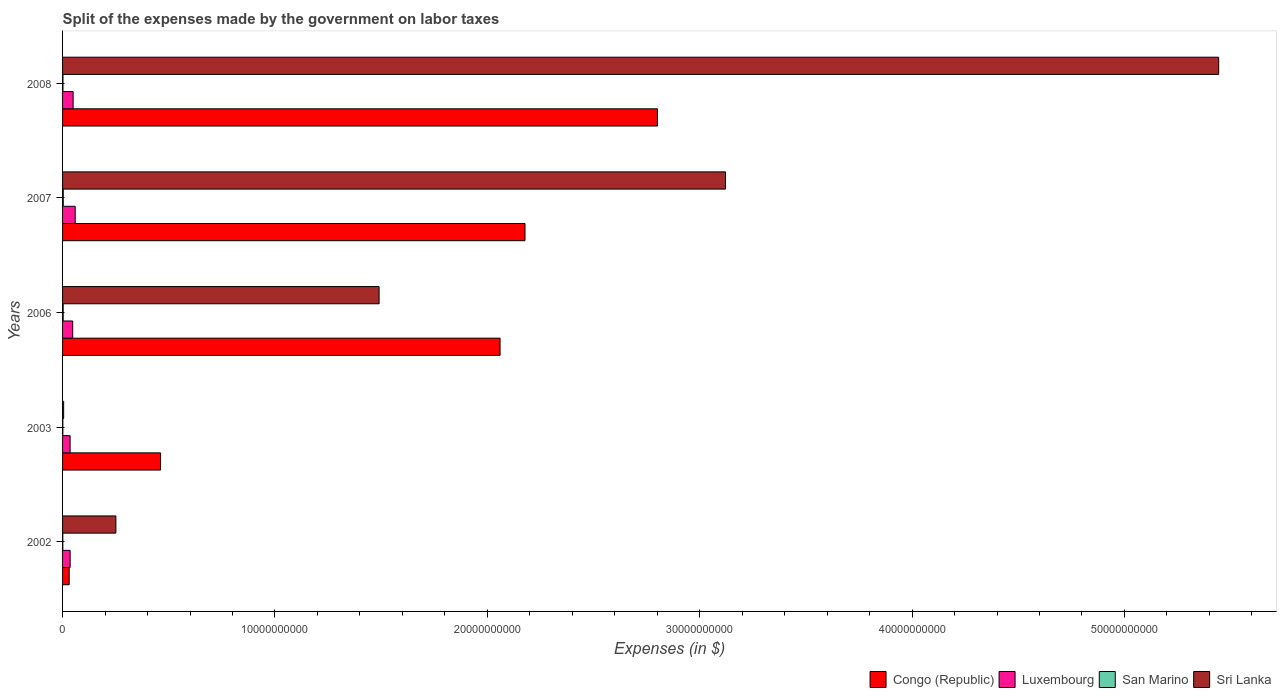Are the number of bars on each tick of the Y-axis equal?
Your answer should be compact. Yes. What is the label of the 5th group of bars from the top?
Provide a succinct answer. 2002. In how many cases, is the number of bars for a given year not equal to the number of legend labels?
Make the answer very short. 0. What is the expenses made by the government on labor taxes in San Marino in 2003?
Provide a succinct answer. 1.21e+07. Across all years, what is the maximum expenses made by the government on labor taxes in Congo (Republic)?
Make the answer very short. 2.80e+1. Across all years, what is the minimum expenses made by the government on labor taxes in San Marino?
Your answer should be compact. 1.16e+07. What is the total expenses made by the government on labor taxes in Congo (Republic) in the graph?
Provide a succinct answer. 7.53e+1. What is the difference between the expenses made by the government on labor taxes in Sri Lanka in 2006 and that in 2007?
Your answer should be very brief. -1.63e+1. What is the difference between the expenses made by the government on labor taxes in Congo (Republic) in 2006 and the expenses made by the government on labor taxes in San Marino in 2008?
Ensure brevity in your answer.  2.06e+1. What is the average expenses made by the government on labor taxes in San Marino per year?
Offer a very short reply. 2.05e+07. In the year 2008, what is the difference between the expenses made by the government on labor taxes in Luxembourg and expenses made by the government on labor taxes in Sri Lanka?
Offer a very short reply. -5.39e+1. In how many years, is the expenses made by the government on labor taxes in Congo (Republic) greater than 26000000000 $?
Ensure brevity in your answer.  1. What is the ratio of the expenses made by the government on labor taxes in San Marino in 2003 to that in 2008?
Your response must be concise. 0.65. Is the expenses made by the government on labor taxes in San Marino in 2002 less than that in 2008?
Your answer should be compact. Yes. What is the difference between the highest and the second highest expenses made by the government on labor taxes in Sri Lanka?
Provide a succinct answer. 2.32e+1. What is the difference between the highest and the lowest expenses made by the government on labor taxes in Luxembourg?
Make the answer very short. 2.40e+08. What does the 1st bar from the top in 2006 represents?
Provide a succinct answer. Sri Lanka. What does the 2nd bar from the bottom in 2006 represents?
Give a very brief answer. Luxembourg. Is it the case that in every year, the sum of the expenses made by the government on labor taxes in San Marino and expenses made by the government on labor taxes in Sri Lanka is greater than the expenses made by the government on labor taxes in Congo (Republic)?
Offer a terse response. No. How many years are there in the graph?
Your answer should be very brief. 5. Where does the legend appear in the graph?
Keep it short and to the point. Bottom right. How many legend labels are there?
Provide a succinct answer. 4. How are the legend labels stacked?
Ensure brevity in your answer.  Horizontal. What is the title of the graph?
Ensure brevity in your answer.  Split of the expenses made by the government on labor taxes. What is the label or title of the X-axis?
Make the answer very short. Expenses (in $). What is the label or title of the Y-axis?
Provide a short and direct response. Years. What is the Expenses (in $) in Congo (Republic) in 2002?
Your answer should be very brief. 3.12e+08. What is the Expenses (in $) of Luxembourg in 2002?
Offer a terse response. 3.56e+08. What is the Expenses (in $) in San Marino in 2002?
Offer a very short reply. 1.16e+07. What is the Expenses (in $) in Sri Lanka in 2002?
Your answer should be compact. 2.51e+09. What is the Expenses (in $) in Congo (Republic) in 2003?
Your answer should be very brief. 4.61e+09. What is the Expenses (in $) in Luxembourg in 2003?
Give a very brief answer. 3.54e+08. What is the Expenses (in $) of San Marino in 2003?
Offer a very short reply. 1.21e+07. What is the Expenses (in $) of Sri Lanka in 2003?
Offer a very short reply. 5.10e+07. What is the Expenses (in $) of Congo (Republic) in 2006?
Your answer should be compact. 2.06e+1. What is the Expenses (in $) of Luxembourg in 2006?
Offer a terse response. 4.78e+08. What is the Expenses (in $) in San Marino in 2006?
Your answer should be compact. 2.84e+07. What is the Expenses (in $) of Sri Lanka in 2006?
Ensure brevity in your answer.  1.49e+1. What is the Expenses (in $) in Congo (Republic) in 2007?
Offer a very short reply. 2.18e+1. What is the Expenses (in $) in Luxembourg in 2007?
Give a very brief answer. 5.95e+08. What is the Expenses (in $) of San Marino in 2007?
Offer a terse response. 3.20e+07. What is the Expenses (in $) in Sri Lanka in 2007?
Provide a succinct answer. 3.12e+1. What is the Expenses (in $) in Congo (Republic) in 2008?
Your response must be concise. 2.80e+1. What is the Expenses (in $) of Luxembourg in 2008?
Your response must be concise. 4.97e+08. What is the Expenses (in $) in San Marino in 2008?
Your response must be concise. 1.87e+07. What is the Expenses (in $) of Sri Lanka in 2008?
Your answer should be compact. 5.44e+1. Across all years, what is the maximum Expenses (in $) in Congo (Republic)?
Provide a short and direct response. 2.80e+1. Across all years, what is the maximum Expenses (in $) of Luxembourg?
Make the answer very short. 5.95e+08. Across all years, what is the maximum Expenses (in $) of San Marino?
Offer a terse response. 3.20e+07. Across all years, what is the maximum Expenses (in $) in Sri Lanka?
Your answer should be compact. 5.44e+1. Across all years, what is the minimum Expenses (in $) of Congo (Republic)?
Your answer should be compact. 3.12e+08. Across all years, what is the minimum Expenses (in $) of Luxembourg?
Your response must be concise. 3.54e+08. Across all years, what is the minimum Expenses (in $) in San Marino?
Offer a very short reply. 1.16e+07. Across all years, what is the minimum Expenses (in $) of Sri Lanka?
Your answer should be compact. 5.10e+07. What is the total Expenses (in $) of Congo (Republic) in the graph?
Your answer should be very brief. 7.53e+1. What is the total Expenses (in $) of Luxembourg in the graph?
Give a very brief answer. 2.28e+09. What is the total Expenses (in $) in San Marino in the graph?
Give a very brief answer. 1.03e+08. What is the total Expenses (in $) of Sri Lanka in the graph?
Make the answer very short. 1.03e+11. What is the difference between the Expenses (in $) in Congo (Republic) in 2002 and that in 2003?
Your answer should be very brief. -4.30e+09. What is the difference between the Expenses (in $) in Luxembourg in 2002 and that in 2003?
Ensure brevity in your answer.  2.10e+06. What is the difference between the Expenses (in $) of San Marino in 2002 and that in 2003?
Offer a terse response. -5.42e+05. What is the difference between the Expenses (in $) in Sri Lanka in 2002 and that in 2003?
Offer a terse response. 2.46e+09. What is the difference between the Expenses (in $) of Congo (Republic) in 2002 and that in 2006?
Keep it short and to the point. -2.03e+1. What is the difference between the Expenses (in $) in Luxembourg in 2002 and that in 2006?
Offer a terse response. -1.22e+08. What is the difference between the Expenses (in $) of San Marino in 2002 and that in 2006?
Your answer should be very brief. -1.69e+07. What is the difference between the Expenses (in $) in Sri Lanka in 2002 and that in 2006?
Provide a short and direct response. -1.24e+1. What is the difference between the Expenses (in $) in Congo (Republic) in 2002 and that in 2007?
Provide a succinct answer. -2.15e+1. What is the difference between the Expenses (in $) of Luxembourg in 2002 and that in 2007?
Your answer should be very brief. -2.38e+08. What is the difference between the Expenses (in $) in San Marino in 2002 and that in 2007?
Provide a short and direct response. -2.04e+07. What is the difference between the Expenses (in $) in Sri Lanka in 2002 and that in 2007?
Your answer should be compact. -2.87e+1. What is the difference between the Expenses (in $) of Congo (Republic) in 2002 and that in 2008?
Offer a terse response. -2.77e+1. What is the difference between the Expenses (in $) of Luxembourg in 2002 and that in 2008?
Make the answer very short. -1.41e+08. What is the difference between the Expenses (in $) in San Marino in 2002 and that in 2008?
Your answer should be very brief. -7.12e+06. What is the difference between the Expenses (in $) in Sri Lanka in 2002 and that in 2008?
Give a very brief answer. -5.19e+1. What is the difference between the Expenses (in $) in Congo (Republic) in 2003 and that in 2006?
Offer a terse response. -1.60e+1. What is the difference between the Expenses (in $) in Luxembourg in 2003 and that in 2006?
Keep it short and to the point. -1.24e+08. What is the difference between the Expenses (in $) of San Marino in 2003 and that in 2006?
Your response must be concise. -1.63e+07. What is the difference between the Expenses (in $) of Sri Lanka in 2003 and that in 2006?
Your response must be concise. -1.49e+1. What is the difference between the Expenses (in $) in Congo (Republic) in 2003 and that in 2007?
Provide a short and direct response. -1.72e+1. What is the difference between the Expenses (in $) in Luxembourg in 2003 and that in 2007?
Provide a succinct answer. -2.40e+08. What is the difference between the Expenses (in $) in San Marino in 2003 and that in 2007?
Your answer should be very brief. -1.99e+07. What is the difference between the Expenses (in $) in Sri Lanka in 2003 and that in 2007?
Provide a short and direct response. -3.12e+1. What is the difference between the Expenses (in $) in Congo (Republic) in 2003 and that in 2008?
Ensure brevity in your answer.  -2.34e+1. What is the difference between the Expenses (in $) in Luxembourg in 2003 and that in 2008?
Provide a short and direct response. -1.43e+08. What is the difference between the Expenses (in $) in San Marino in 2003 and that in 2008?
Give a very brief answer. -6.58e+06. What is the difference between the Expenses (in $) in Sri Lanka in 2003 and that in 2008?
Make the answer very short. -5.44e+1. What is the difference between the Expenses (in $) of Congo (Republic) in 2006 and that in 2007?
Provide a short and direct response. -1.17e+09. What is the difference between the Expenses (in $) of Luxembourg in 2006 and that in 2007?
Provide a short and direct response. -1.17e+08. What is the difference between the Expenses (in $) of San Marino in 2006 and that in 2007?
Offer a very short reply. -3.56e+06. What is the difference between the Expenses (in $) of Sri Lanka in 2006 and that in 2007?
Your response must be concise. -1.63e+1. What is the difference between the Expenses (in $) in Congo (Republic) in 2006 and that in 2008?
Give a very brief answer. -7.41e+09. What is the difference between the Expenses (in $) of Luxembourg in 2006 and that in 2008?
Your response must be concise. -1.92e+07. What is the difference between the Expenses (in $) in San Marino in 2006 and that in 2008?
Keep it short and to the point. 9.73e+06. What is the difference between the Expenses (in $) in Sri Lanka in 2006 and that in 2008?
Offer a very short reply. -3.95e+1. What is the difference between the Expenses (in $) of Congo (Republic) in 2007 and that in 2008?
Make the answer very short. -6.24e+09. What is the difference between the Expenses (in $) in Luxembourg in 2007 and that in 2008?
Give a very brief answer. 9.75e+07. What is the difference between the Expenses (in $) of San Marino in 2007 and that in 2008?
Offer a terse response. 1.33e+07. What is the difference between the Expenses (in $) of Sri Lanka in 2007 and that in 2008?
Keep it short and to the point. -2.32e+1. What is the difference between the Expenses (in $) in Congo (Republic) in 2002 and the Expenses (in $) in Luxembourg in 2003?
Give a very brief answer. -4.24e+07. What is the difference between the Expenses (in $) of Congo (Republic) in 2002 and the Expenses (in $) of San Marino in 2003?
Make the answer very short. 3.00e+08. What is the difference between the Expenses (in $) of Congo (Republic) in 2002 and the Expenses (in $) of Sri Lanka in 2003?
Keep it short and to the point. 2.61e+08. What is the difference between the Expenses (in $) in Luxembourg in 2002 and the Expenses (in $) in San Marino in 2003?
Offer a very short reply. 3.44e+08. What is the difference between the Expenses (in $) of Luxembourg in 2002 and the Expenses (in $) of Sri Lanka in 2003?
Ensure brevity in your answer.  3.05e+08. What is the difference between the Expenses (in $) in San Marino in 2002 and the Expenses (in $) in Sri Lanka in 2003?
Offer a very short reply. -3.94e+07. What is the difference between the Expenses (in $) in Congo (Republic) in 2002 and the Expenses (in $) in Luxembourg in 2006?
Ensure brevity in your answer.  -1.66e+08. What is the difference between the Expenses (in $) of Congo (Republic) in 2002 and the Expenses (in $) of San Marino in 2006?
Make the answer very short. 2.83e+08. What is the difference between the Expenses (in $) of Congo (Republic) in 2002 and the Expenses (in $) of Sri Lanka in 2006?
Make the answer very short. -1.46e+1. What is the difference between the Expenses (in $) of Luxembourg in 2002 and the Expenses (in $) of San Marino in 2006?
Your answer should be very brief. 3.28e+08. What is the difference between the Expenses (in $) of Luxembourg in 2002 and the Expenses (in $) of Sri Lanka in 2006?
Your response must be concise. -1.45e+1. What is the difference between the Expenses (in $) in San Marino in 2002 and the Expenses (in $) in Sri Lanka in 2006?
Give a very brief answer. -1.49e+1. What is the difference between the Expenses (in $) of Congo (Republic) in 2002 and the Expenses (in $) of Luxembourg in 2007?
Provide a short and direct response. -2.83e+08. What is the difference between the Expenses (in $) in Congo (Republic) in 2002 and the Expenses (in $) in San Marino in 2007?
Make the answer very short. 2.80e+08. What is the difference between the Expenses (in $) of Congo (Republic) in 2002 and the Expenses (in $) of Sri Lanka in 2007?
Your answer should be very brief. -3.09e+1. What is the difference between the Expenses (in $) in Luxembourg in 2002 and the Expenses (in $) in San Marino in 2007?
Make the answer very short. 3.24e+08. What is the difference between the Expenses (in $) in Luxembourg in 2002 and the Expenses (in $) in Sri Lanka in 2007?
Make the answer very short. -3.09e+1. What is the difference between the Expenses (in $) of San Marino in 2002 and the Expenses (in $) of Sri Lanka in 2007?
Keep it short and to the point. -3.12e+1. What is the difference between the Expenses (in $) in Congo (Republic) in 2002 and the Expenses (in $) in Luxembourg in 2008?
Provide a short and direct response. -1.85e+08. What is the difference between the Expenses (in $) of Congo (Republic) in 2002 and the Expenses (in $) of San Marino in 2008?
Give a very brief answer. 2.93e+08. What is the difference between the Expenses (in $) of Congo (Republic) in 2002 and the Expenses (in $) of Sri Lanka in 2008?
Your answer should be compact. -5.41e+1. What is the difference between the Expenses (in $) of Luxembourg in 2002 and the Expenses (in $) of San Marino in 2008?
Give a very brief answer. 3.38e+08. What is the difference between the Expenses (in $) of Luxembourg in 2002 and the Expenses (in $) of Sri Lanka in 2008?
Offer a very short reply. -5.41e+1. What is the difference between the Expenses (in $) of San Marino in 2002 and the Expenses (in $) of Sri Lanka in 2008?
Offer a terse response. -5.44e+1. What is the difference between the Expenses (in $) of Congo (Republic) in 2003 and the Expenses (in $) of Luxembourg in 2006?
Your answer should be compact. 4.14e+09. What is the difference between the Expenses (in $) of Congo (Republic) in 2003 and the Expenses (in $) of San Marino in 2006?
Provide a succinct answer. 4.59e+09. What is the difference between the Expenses (in $) of Congo (Republic) in 2003 and the Expenses (in $) of Sri Lanka in 2006?
Offer a terse response. -1.03e+1. What is the difference between the Expenses (in $) of Luxembourg in 2003 and the Expenses (in $) of San Marino in 2006?
Give a very brief answer. 3.26e+08. What is the difference between the Expenses (in $) of Luxembourg in 2003 and the Expenses (in $) of Sri Lanka in 2006?
Your answer should be very brief. -1.46e+1. What is the difference between the Expenses (in $) of San Marino in 2003 and the Expenses (in $) of Sri Lanka in 2006?
Give a very brief answer. -1.49e+1. What is the difference between the Expenses (in $) in Congo (Republic) in 2003 and the Expenses (in $) in Luxembourg in 2007?
Your response must be concise. 4.02e+09. What is the difference between the Expenses (in $) in Congo (Republic) in 2003 and the Expenses (in $) in San Marino in 2007?
Give a very brief answer. 4.58e+09. What is the difference between the Expenses (in $) in Congo (Republic) in 2003 and the Expenses (in $) in Sri Lanka in 2007?
Provide a succinct answer. -2.66e+1. What is the difference between the Expenses (in $) in Luxembourg in 2003 and the Expenses (in $) in San Marino in 2007?
Provide a succinct answer. 3.22e+08. What is the difference between the Expenses (in $) of Luxembourg in 2003 and the Expenses (in $) of Sri Lanka in 2007?
Make the answer very short. -3.09e+1. What is the difference between the Expenses (in $) of San Marino in 2003 and the Expenses (in $) of Sri Lanka in 2007?
Your answer should be compact. -3.12e+1. What is the difference between the Expenses (in $) in Congo (Republic) in 2003 and the Expenses (in $) in Luxembourg in 2008?
Keep it short and to the point. 4.12e+09. What is the difference between the Expenses (in $) in Congo (Republic) in 2003 and the Expenses (in $) in San Marino in 2008?
Offer a terse response. 4.60e+09. What is the difference between the Expenses (in $) of Congo (Republic) in 2003 and the Expenses (in $) of Sri Lanka in 2008?
Give a very brief answer. -4.98e+1. What is the difference between the Expenses (in $) in Luxembourg in 2003 and the Expenses (in $) in San Marino in 2008?
Provide a succinct answer. 3.36e+08. What is the difference between the Expenses (in $) of Luxembourg in 2003 and the Expenses (in $) of Sri Lanka in 2008?
Provide a short and direct response. -5.41e+1. What is the difference between the Expenses (in $) of San Marino in 2003 and the Expenses (in $) of Sri Lanka in 2008?
Provide a short and direct response. -5.44e+1. What is the difference between the Expenses (in $) in Congo (Republic) in 2006 and the Expenses (in $) in Luxembourg in 2007?
Offer a very short reply. 2.00e+1. What is the difference between the Expenses (in $) in Congo (Republic) in 2006 and the Expenses (in $) in San Marino in 2007?
Ensure brevity in your answer.  2.06e+1. What is the difference between the Expenses (in $) of Congo (Republic) in 2006 and the Expenses (in $) of Sri Lanka in 2007?
Offer a terse response. -1.06e+1. What is the difference between the Expenses (in $) of Luxembourg in 2006 and the Expenses (in $) of San Marino in 2007?
Keep it short and to the point. 4.46e+08. What is the difference between the Expenses (in $) of Luxembourg in 2006 and the Expenses (in $) of Sri Lanka in 2007?
Offer a terse response. -3.07e+1. What is the difference between the Expenses (in $) of San Marino in 2006 and the Expenses (in $) of Sri Lanka in 2007?
Ensure brevity in your answer.  -3.12e+1. What is the difference between the Expenses (in $) of Congo (Republic) in 2006 and the Expenses (in $) of Luxembourg in 2008?
Make the answer very short. 2.01e+1. What is the difference between the Expenses (in $) in Congo (Republic) in 2006 and the Expenses (in $) in San Marino in 2008?
Provide a succinct answer. 2.06e+1. What is the difference between the Expenses (in $) in Congo (Republic) in 2006 and the Expenses (in $) in Sri Lanka in 2008?
Offer a terse response. -3.38e+1. What is the difference between the Expenses (in $) of Luxembourg in 2006 and the Expenses (in $) of San Marino in 2008?
Offer a very short reply. 4.59e+08. What is the difference between the Expenses (in $) of Luxembourg in 2006 and the Expenses (in $) of Sri Lanka in 2008?
Ensure brevity in your answer.  -5.40e+1. What is the difference between the Expenses (in $) of San Marino in 2006 and the Expenses (in $) of Sri Lanka in 2008?
Give a very brief answer. -5.44e+1. What is the difference between the Expenses (in $) in Congo (Republic) in 2007 and the Expenses (in $) in Luxembourg in 2008?
Offer a very short reply. 2.13e+1. What is the difference between the Expenses (in $) in Congo (Republic) in 2007 and the Expenses (in $) in San Marino in 2008?
Make the answer very short. 2.18e+1. What is the difference between the Expenses (in $) in Congo (Republic) in 2007 and the Expenses (in $) in Sri Lanka in 2008?
Your answer should be very brief. -3.27e+1. What is the difference between the Expenses (in $) of Luxembourg in 2007 and the Expenses (in $) of San Marino in 2008?
Give a very brief answer. 5.76e+08. What is the difference between the Expenses (in $) of Luxembourg in 2007 and the Expenses (in $) of Sri Lanka in 2008?
Provide a short and direct response. -5.38e+1. What is the difference between the Expenses (in $) of San Marino in 2007 and the Expenses (in $) of Sri Lanka in 2008?
Ensure brevity in your answer.  -5.44e+1. What is the average Expenses (in $) in Congo (Republic) per year?
Provide a succinct answer. 1.51e+1. What is the average Expenses (in $) in Luxembourg per year?
Give a very brief answer. 4.56e+08. What is the average Expenses (in $) in San Marino per year?
Keep it short and to the point. 2.05e+07. What is the average Expenses (in $) of Sri Lanka per year?
Offer a terse response. 2.06e+1. In the year 2002, what is the difference between the Expenses (in $) in Congo (Republic) and Expenses (in $) in Luxembourg?
Provide a succinct answer. -4.45e+07. In the year 2002, what is the difference between the Expenses (in $) in Congo (Republic) and Expenses (in $) in San Marino?
Ensure brevity in your answer.  3.00e+08. In the year 2002, what is the difference between the Expenses (in $) in Congo (Republic) and Expenses (in $) in Sri Lanka?
Ensure brevity in your answer.  -2.20e+09. In the year 2002, what is the difference between the Expenses (in $) in Luxembourg and Expenses (in $) in San Marino?
Offer a terse response. 3.45e+08. In the year 2002, what is the difference between the Expenses (in $) in Luxembourg and Expenses (in $) in Sri Lanka?
Keep it short and to the point. -2.15e+09. In the year 2002, what is the difference between the Expenses (in $) in San Marino and Expenses (in $) in Sri Lanka?
Your answer should be compact. -2.50e+09. In the year 2003, what is the difference between the Expenses (in $) of Congo (Republic) and Expenses (in $) of Luxembourg?
Offer a terse response. 4.26e+09. In the year 2003, what is the difference between the Expenses (in $) of Congo (Republic) and Expenses (in $) of San Marino?
Offer a terse response. 4.60e+09. In the year 2003, what is the difference between the Expenses (in $) in Congo (Republic) and Expenses (in $) in Sri Lanka?
Your answer should be compact. 4.56e+09. In the year 2003, what is the difference between the Expenses (in $) in Luxembourg and Expenses (in $) in San Marino?
Provide a succinct answer. 3.42e+08. In the year 2003, what is the difference between the Expenses (in $) in Luxembourg and Expenses (in $) in Sri Lanka?
Make the answer very short. 3.03e+08. In the year 2003, what is the difference between the Expenses (in $) of San Marino and Expenses (in $) of Sri Lanka?
Make the answer very short. -3.89e+07. In the year 2006, what is the difference between the Expenses (in $) in Congo (Republic) and Expenses (in $) in Luxembourg?
Ensure brevity in your answer.  2.01e+1. In the year 2006, what is the difference between the Expenses (in $) of Congo (Republic) and Expenses (in $) of San Marino?
Your response must be concise. 2.06e+1. In the year 2006, what is the difference between the Expenses (in $) of Congo (Republic) and Expenses (in $) of Sri Lanka?
Provide a succinct answer. 5.70e+09. In the year 2006, what is the difference between the Expenses (in $) in Luxembourg and Expenses (in $) in San Marino?
Provide a succinct answer. 4.50e+08. In the year 2006, what is the difference between the Expenses (in $) in Luxembourg and Expenses (in $) in Sri Lanka?
Ensure brevity in your answer.  -1.44e+1. In the year 2006, what is the difference between the Expenses (in $) of San Marino and Expenses (in $) of Sri Lanka?
Keep it short and to the point. -1.49e+1. In the year 2007, what is the difference between the Expenses (in $) of Congo (Republic) and Expenses (in $) of Luxembourg?
Ensure brevity in your answer.  2.12e+1. In the year 2007, what is the difference between the Expenses (in $) in Congo (Republic) and Expenses (in $) in San Marino?
Your answer should be very brief. 2.17e+1. In the year 2007, what is the difference between the Expenses (in $) of Congo (Republic) and Expenses (in $) of Sri Lanka?
Your answer should be compact. -9.44e+09. In the year 2007, what is the difference between the Expenses (in $) in Luxembourg and Expenses (in $) in San Marino?
Your response must be concise. 5.63e+08. In the year 2007, what is the difference between the Expenses (in $) of Luxembourg and Expenses (in $) of Sri Lanka?
Ensure brevity in your answer.  -3.06e+1. In the year 2007, what is the difference between the Expenses (in $) of San Marino and Expenses (in $) of Sri Lanka?
Give a very brief answer. -3.12e+1. In the year 2008, what is the difference between the Expenses (in $) in Congo (Republic) and Expenses (in $) in Luxembourg?
Offer a very short reply. 2.75e+1. In the year 2008, what is the difference between the Expenses (in $) in Congo (Republic) and Expenses (in $) in San Marino?
Keep it short and to the point. 2.80e+1. In the year 2008, what is the difference between the Expenses (in $) of Congo (Republic) and Expenses (in $) of Sri Lanka?
Ensure brevity in your answer.  -2.64e+1. In the year 2008, what is the difference between the Expenses (in $) in Luxembourg and Expenses (in $) in San Marino?
Provide a succinct answer. 4.79e+08. In the year 2008, what is the difference between the Expenses (in $) of Luxembourg and Expenses (in $) of Sri Lanka?
Your response must be concise. -5.39e+1. In the year 2008, what is the difference between the Expenses (in $) in San Marino and Expenses (in $) in Sri Lanka?
Your response must be concise. -5.44e+1. What is the ratio of the Expenses (in $) in Congo (Republic) in 2002 to that in 2003?
Provide a short and direct response. 0.07. What is the ratio of the Expenses (in $) in Luxembourg in 2002 to that in 2003?
Give a very brief answer. 1.01. What is the ratio of the Expenses (in $) in San Marino in 2002 to that in 2003?
Your answer should be compact. 0.96. What is the ratio of the Expenses (in $) of Sri Lanka in 2002 to that in 2003?
Offer a terse response. 49.24. What is the ratio of the Expenses (in $) in Congo (Republic) in 2002 to that in 2006?
Ensure brevity in your answer.  0.02. What is the ratio of the Expenses (in $) in Luxembourg in 2002 to that in 2006?
Your answer should be very brief. 0.75. What is the ratio of the Expenses (in $) in San Marino in 2002 to that in 2006?
Your answer should be very brief. 0.41. What is the ratio of the Expenses (in $) in Sri Lanka in 2002 to that in 2006?
Keep it short and to the point. 0.17. What is the ratio of the Expenses (in $) of Congo (Republic) in 2002 to that in 2007?
Provide a short and direct response. 0.01. What is the ratio of the Expenses (in $) in Luxembourg in 2002 to that in 2007?
Offer a terse response. 0.6. What is the ratio of the Expenses (in $) of San Marino in 2002 to that in 2007?
Offer a terse response. 0.36. What is the ratio of the Expenses (in $) of Sri Lanka in 2002 to that in 2007?
Make the answer very short. 0.08. What is the ratio of the Expenses (in $) of Congo (Republic) in 2002 to that in 2008?
Make the answer very short. 0.01. What is the ratio of the Expenses (in $) in Luxembourg in 2002 to that in 2008?
Offer a terse response. 0.72. What is the ratio of the Expenses (in $) of San Marino in 2002 to that in 2008?
Provide a short and direct response. 0.62. What is the ratio of the Expenses (in $) of Sri Lanka in 2002 to that in 2008?
Your answer should be very brief. 0.05. What is the ratio of the Expenses (in $) in Congo (Republic) in 2003 to that in 2006?
Provide a succinct answer. 0.22. What is the ratio of the Expenses (in $) of Luxembourg in 2003 to that in 2006?
Offer a very short reply. 0.74. What is the ratio of the Expenses (in $) in San Marino in 2003 to that in 2006?
Provide a succinct answer. 0.43. What is the ratio of the Expenses (in $) of Sri Lanka in 2003 to that in 2006?
Offer a very short reply. 0. What is the ratio of the Expenses (in $) in Congo (Republic) in 2003 to that in 2007?
Keep it short and to the point. 0.21. What is the ratio of the Expenses (in $) in Luxembourg in 2003 to that in 2007?
Your answer should be very brief. 0.6. What is the ratio of the Expenses (in $) of San Marino in 2003 to that in 2007?
Offer a terse response. 0.38. What is the ratio of the Expenses (in $) of Sri Lanka in 2003 to that in 2007?
Make the answer very short. 0. What is the ratio of the Expenses (in $) of Congo (Republic) in 2003 to that in 2008?
Your response must be concise. 0.16. What is the ratio of the Expenses (in $) of Luxembourg in 2003 to that in 2008?
Offer a terse response. 0.71. What is the ratio of the Expenses (in $) of San Marino in 2003 to that in 2008?
Your answer should be compact. 0.65. What is the ratio of the Expenses (in $) in Sri Lanka in 2003 to that in 2008?
Keep it short and to the point. 0. What is the ratio of the Expenses (in $) of Congo (Republic) in 2006 to that in 2007?
Keep it short and to the point. 0.95. What is the ratio of the Expenses (in $) in Luxembourg in 2006 to that in 2007?
Your answer should be very brief. 0.8. What is the ratio of the Expenses (in $) in San Marino in 2006 to that in 2007?
Make the answer very short. 0.89. What is the ratio of the Expenses (in $) in Sri Lanka in 2006 to that in 2007?
Make the answer very short. 0.48. What is the ratio of the Expenses (in $) of Congo (Republic) in 2006 to that in 2008?
Ensure brevity in your answer.  0.74. What is the ratio of the Expenses (in $) of Luxembourg in 2006 to that in 2008?
Your response must be concise. 0.96. What is the ratio of the Expenses (in $) in San Marino in 2006 to that in 2008?
Your answer should be very brief. 1.52. What is the ratio of the Expenses (in $) in Sri Lanka in 2006 to that in 2008?
Ensure brevity in your answer.  0.27. What is the ratio of the Expenses (in $) in Congo (Republic) in 2007 to that in 2008?
Keep it short and to the point. 0.78. What is the ratio of the Expenses (in $) of Luxembourg in 2007 to that in 2008?
Keep it short and to the point. 1.2. What is the ratio of the Expenses (in $) in San Marino in 2007 to that in 2008?
Your response must be concise. 1.71. What is the ratio of the Expenses (in $) in Sri Lanka in 2007 to that in 2008?
Provide a succinct answer. 0.57. What is the difference between the highest and the second highest Expenses (in $) of Congo (Republic)?
Provide a succinct answer. 6.24e+09. What is the difference between the highest and the second highest Expenses (in $) in Luxembourg?
Provide a succinct answer. 9.75e+07. What is the difference between the highest and the second highest Expenses (in $) in San Marino?
Your response must be concise. 3.56e+06. What is the difference between the highest and the second highest Expenses (in $) of Sri Lanka?
Make the answer very short. 2.32e+1. What is the difference between the highest and the lowest Expenses (in $) in Congo (Republic)?
Keep it short and to the point. 2.77e+1. What is the difference between the highest and the lowest Expenses (in $) in Luxembourg?
Provide a short and direct response. 2.40e+08. What is the difference between the highest and the lowest Expenses (in $) of San Marino?
Your answer should be compact. 2.04e+07. What is the difference between the highest and the lowest Expenses (in $) of Sri Lanka?
Provide a short and direct response. 5.44e+1. 